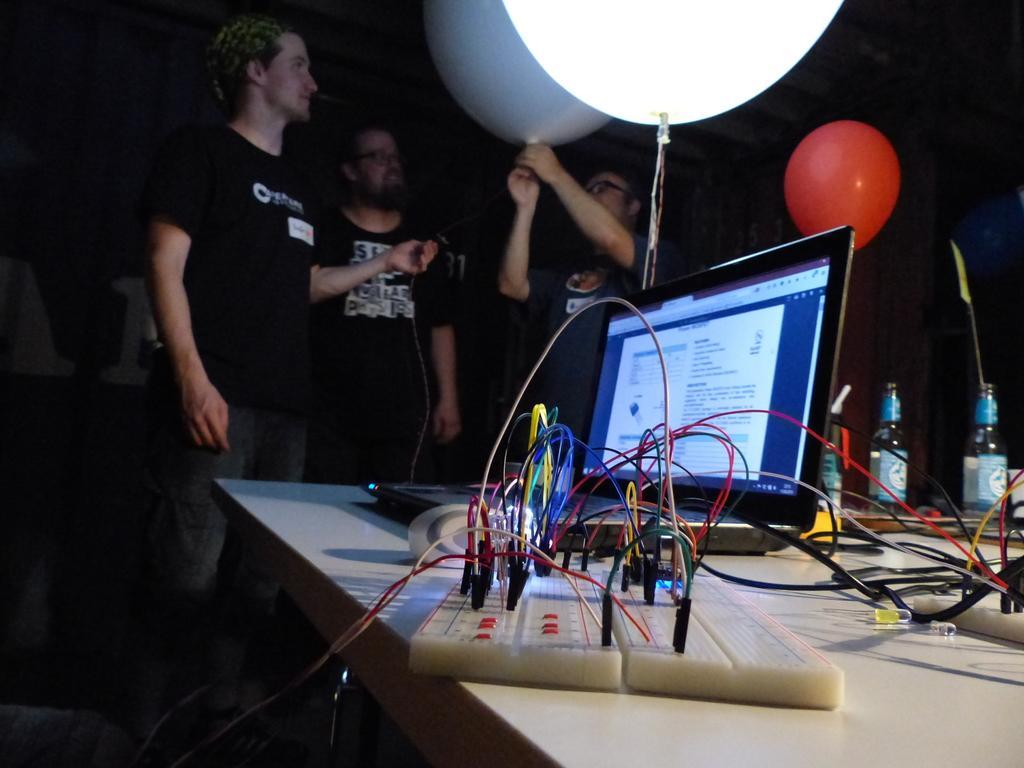Can you describe this image briefly? In this image I can see three people standing. I can see three balloons, a monitor and some bottles on a table. I can see some electronic devices and wires on the table. This picture is taken in the dark. 